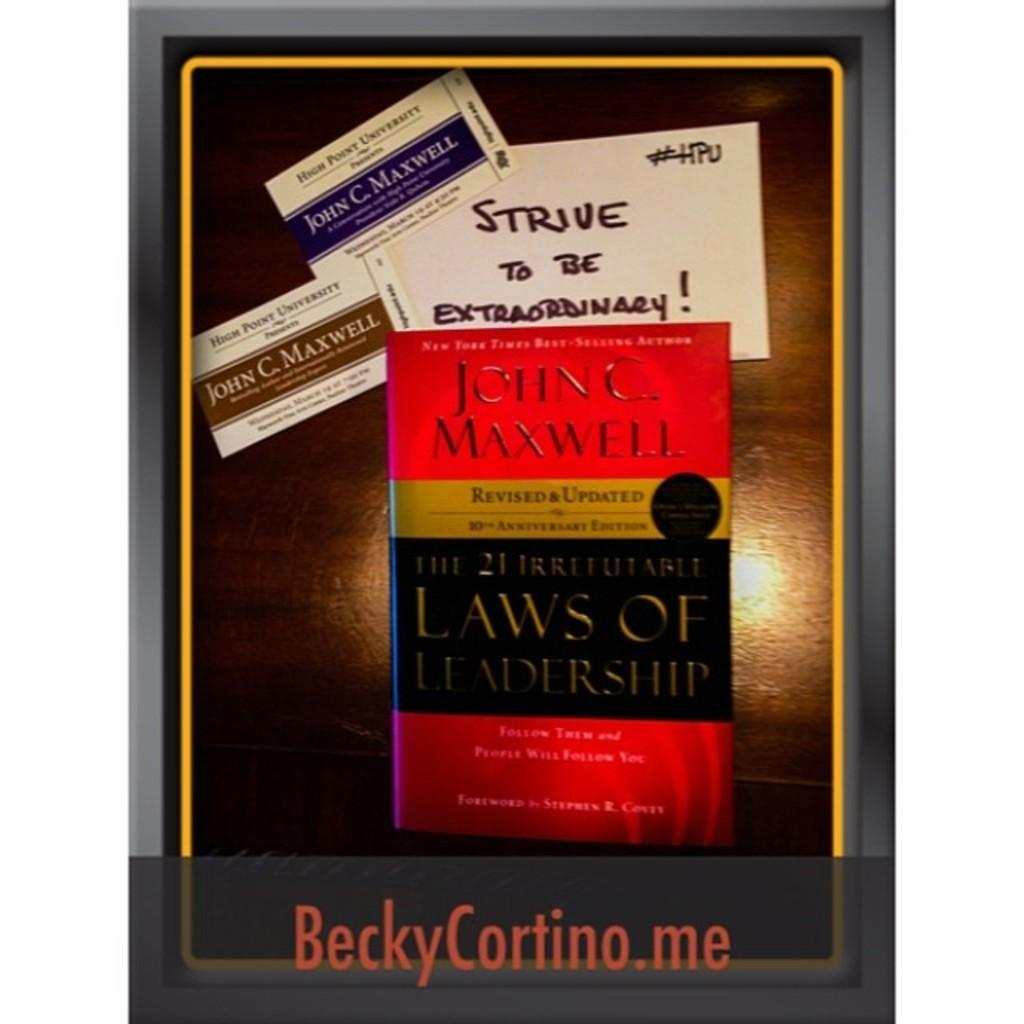Provide a one-sentence caption for the provided image. Two business cards and a book on leadership by John C. Maxwell. 